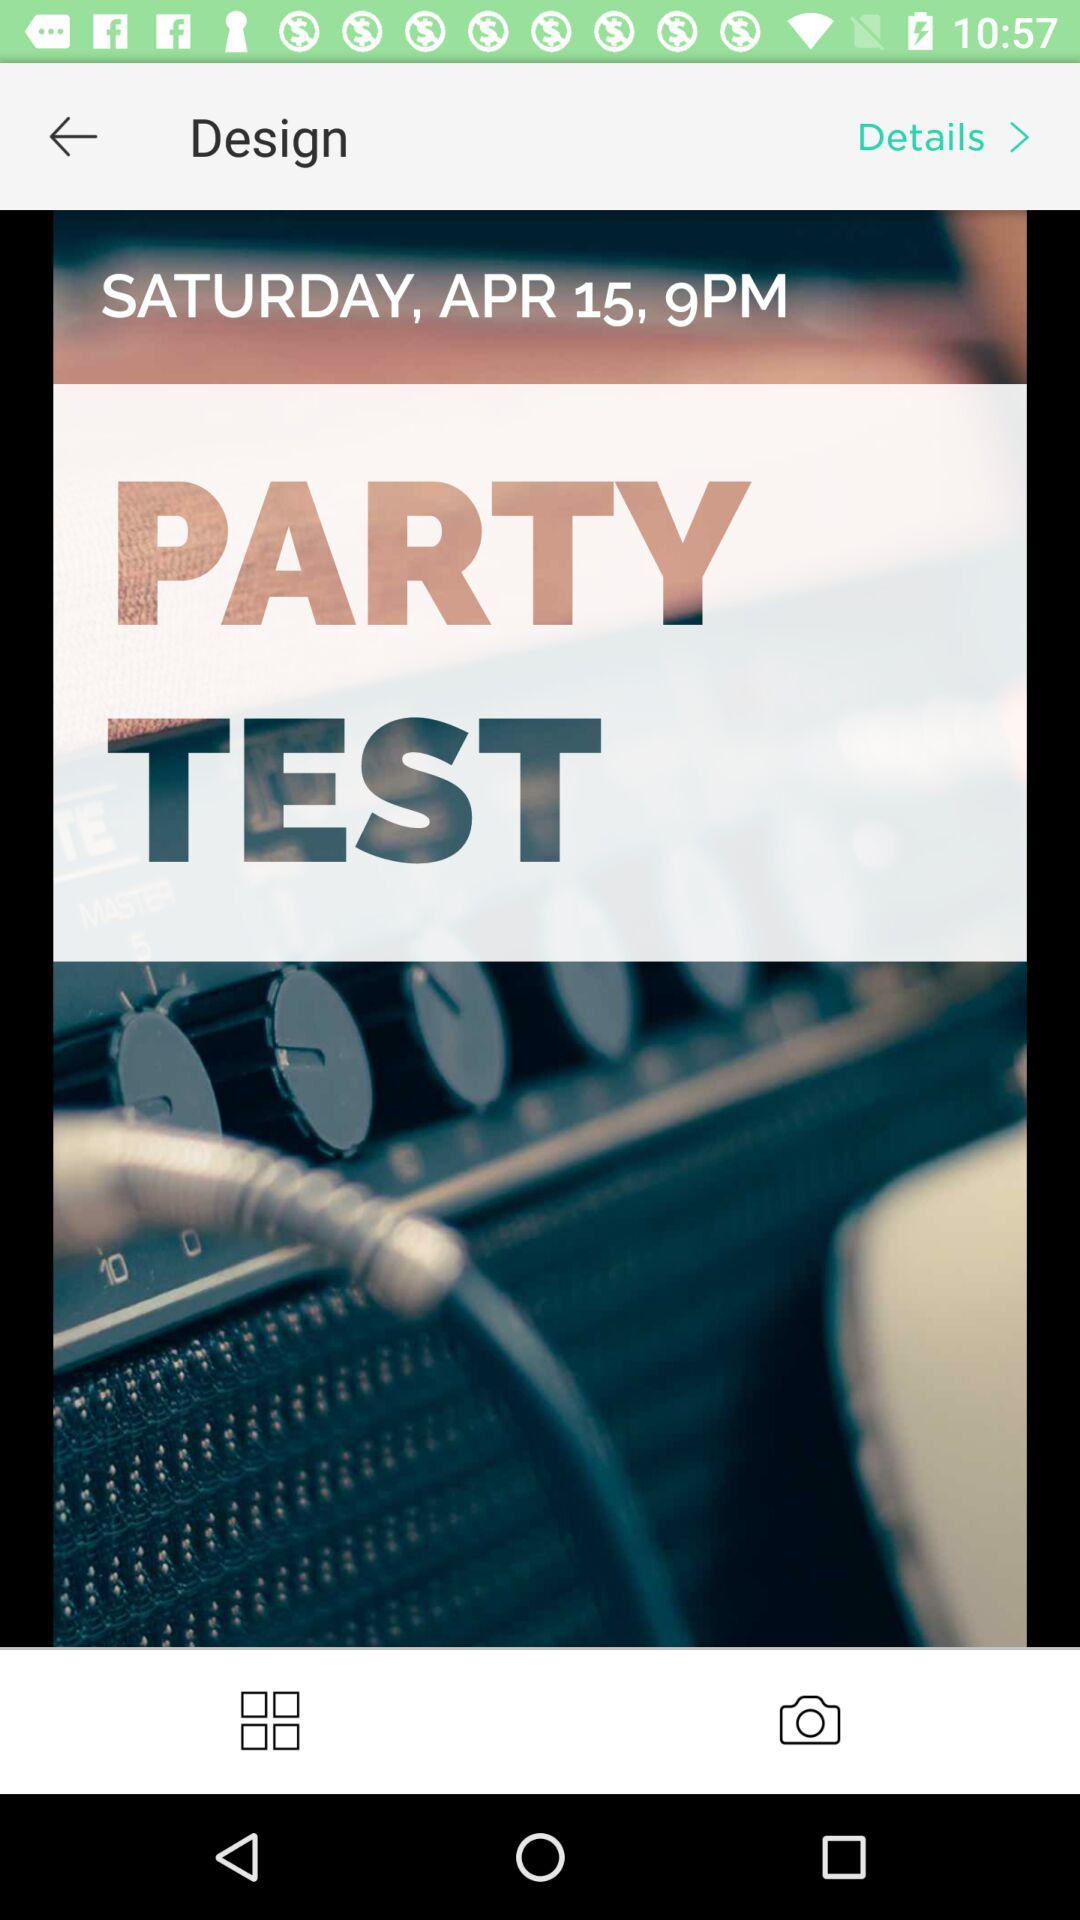At what time is the test organized? The test is organized at 9 PM. 